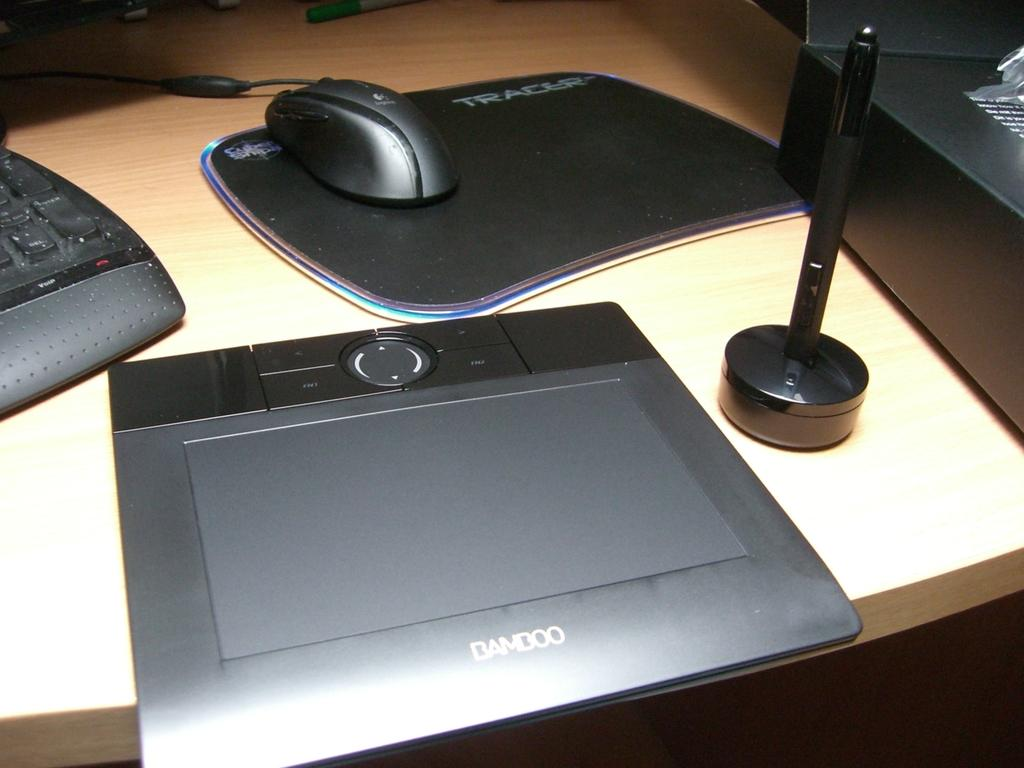What type of animal is in the image? There is a mouse in the image. What is the mouse standing on or near? There is a mouse pad in the image. Are there any other objects on the mouse pad? Yes, there are other objects on the mouse pad. How many frogs are sitting on the button in the image? There are no frogs or buttons present in the image. What is the mouse's opinion on the current political climate? The image does not provide any information about the mouse's opinion on the current political climate. 